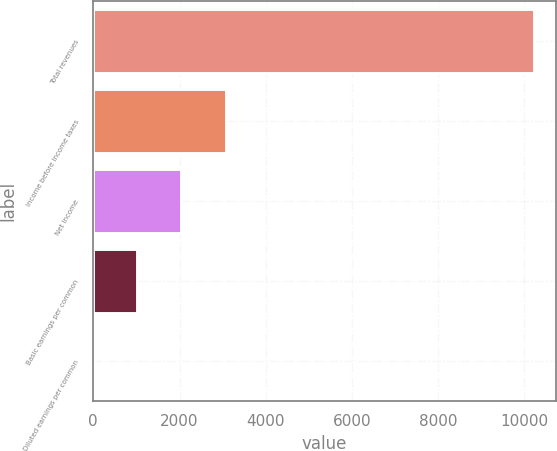Convert chart to OTSL. <chart><loc_0><loc_0><loc_500><loc_500><bar_chart><fcel>Total revenues<fcel>Income before income taxes<fcel>Net income<fcel>Basic earnings per common<fcel>Diluted earnings per common<nl><fcel>10219<fcel>3066.74<fcel>2044.99<fcel>1023.24<fcel>1.49<nl></chart> 